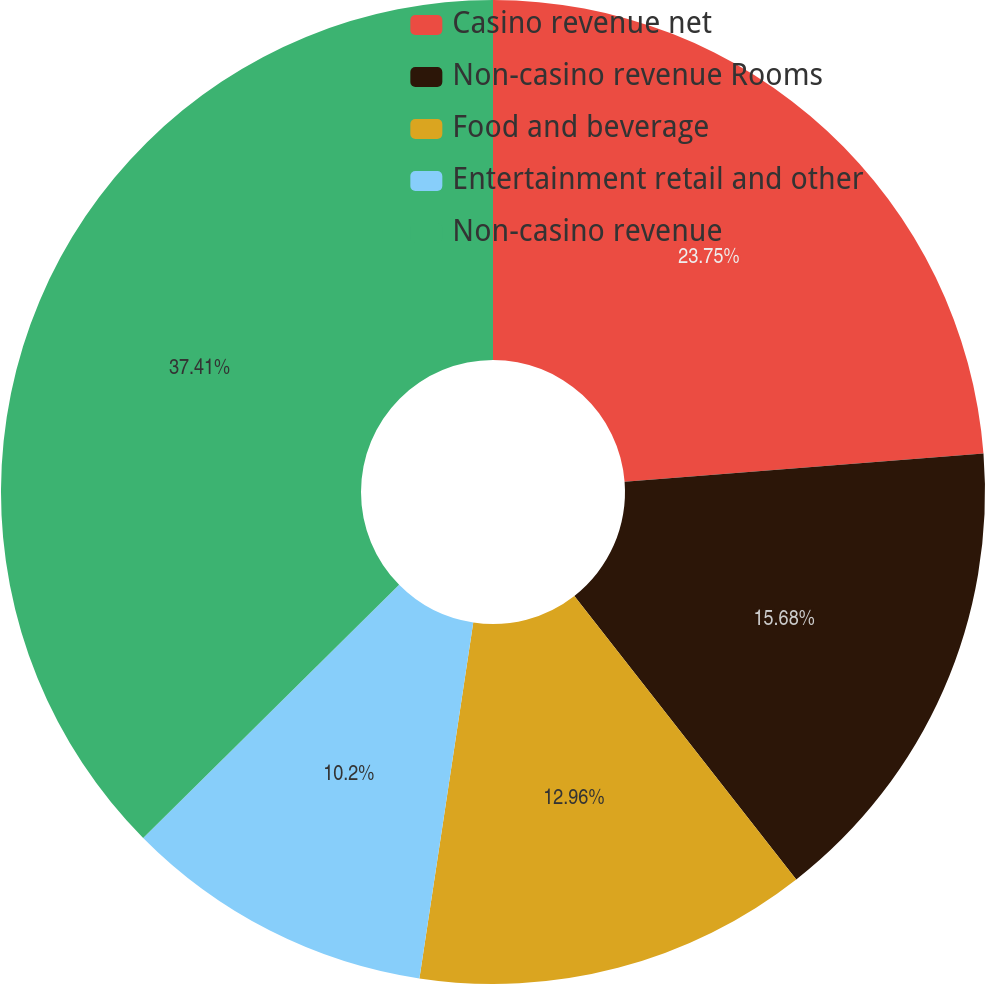Convert chart to OTSL. <chart><loc_0><loc_0><loc_500><loc_500><pie_chart><fcel>Casino revenue net<fcel>Non-casino revenue Rooms<fcel>Food and beverage<fcel>Entertainment retail and other<fcel>Non-casino revenue<nl><fcel>23.75%<fcel>15.68%<fcel>12.96%<fcel>10.2%<fcel>37.41%<nl></chart> 